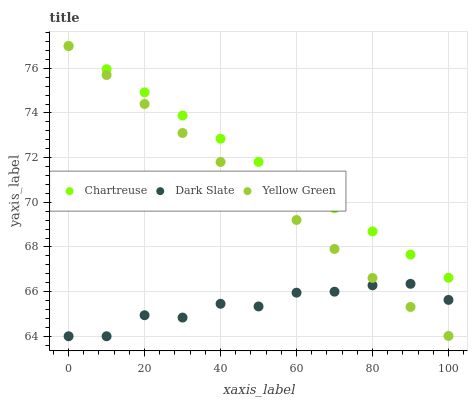Does Dark Slate have the minimum area under the curve?
Answer yes or no. Yes. Does Chartreuse have the maximum area under the curve?
Answer yes or no. Yes. Does Yellow Green have the minimum area under the curve?
Answer yes or no. No. Does Yellow Green have the maximum area under the curve?
Answer yes or no. No. Is Yellow Green the smoothest?
Answer yes or no. Yes. Is Dark Slate the roughest?
Answer yes or no. Yes. Is Chartreuse the smoothest?
Answer yes or no. No. Is Chartreuse the roughest?
Answer yes or no. No. Does Dark Slate have the lowest value?
Answer yes or no. Yes. Does Yellow Green have the lowest value?
Answer yes or no. No. Does Yellow Green have the highest value?
Answer yes or no. Yes. Is Dark Slate less than Chartreuse?
Answer yes or no. Yes. Is Chartreuse greater than Dark Slate?
Answer yes or no. Yes. Does Chartreuse intersect Yellow Green?
Answer yes or no. Yes. Is Chartreuse less than Yellow Green?
Answer yes or no. No. Is Chartreuse greater than Yellow Green?
Answer yes or no. No. Does Dark Slate intersect Chartreuse?
Answer yes or no. No. 